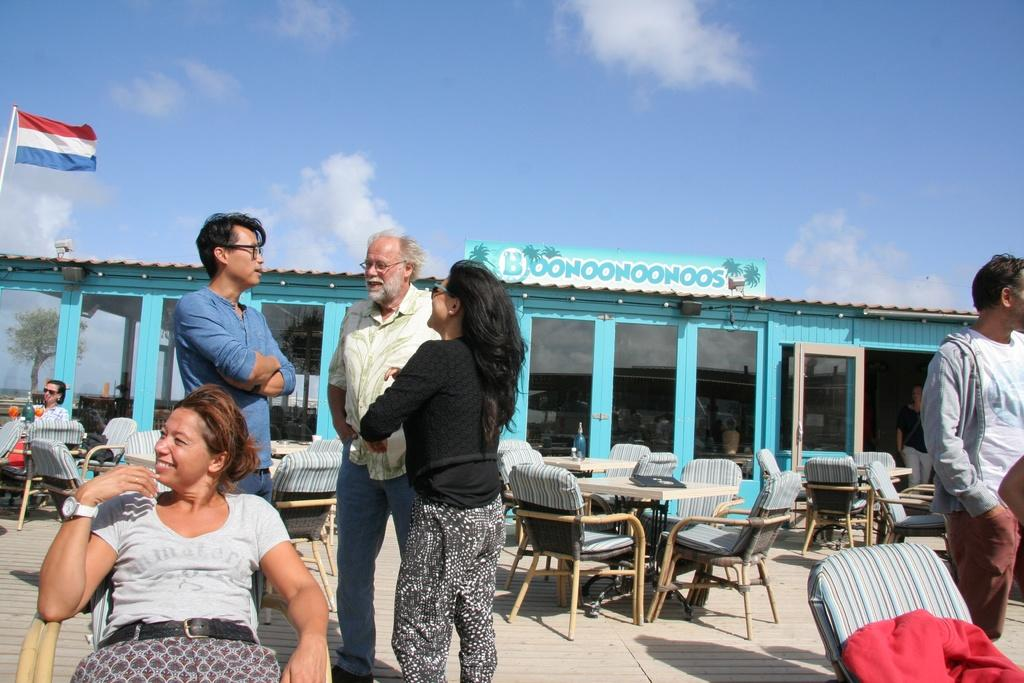What can be seen in the sky in the image? There are clouds visible in the image. What type of furniture is in front of the store? There are chairs and tables in front of the store. Are there any people present in the image? Yes, there are people in front of the store. What is the reflection of in the image? There is a reflection of a tree on a glass surface. Where is the flag located in the image? The flag is on the left side of the image. What type of playground equipment can be seen in the image? There is no playground equipment present in the image. What time of day is depicted in the image? The time of day cannot be determined from the image. 